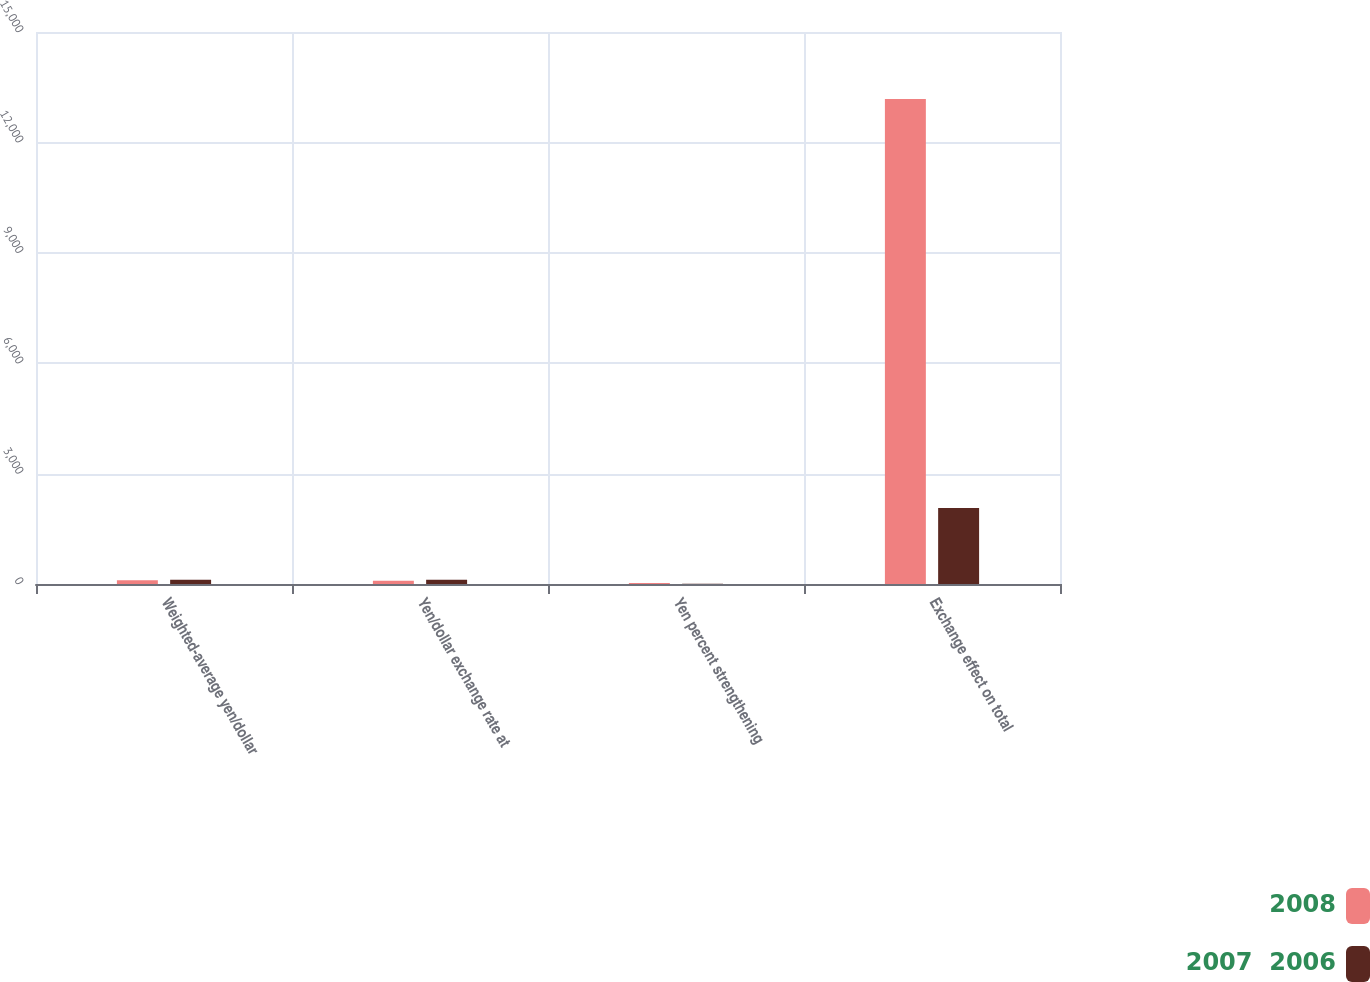Convert chart to OTSL. <chart><loc_0><loc_0><loc_500><loc_500><stacked_bar_chart><ecel><fcel>Weighted-average yen/dollar<fcel>Yen/dollar exchange rate at<fcel>Yen percent strengthening<fcel>Exchange effect on total<nl><fcel>2008<fcel>103.46<fcel>91.03<fcel>25.4<fcel>13180<nl><fcel>2007  2006<fcel>116.31<fcel>114.15<fcel>4.3<fcel>2063<nl></chart> 